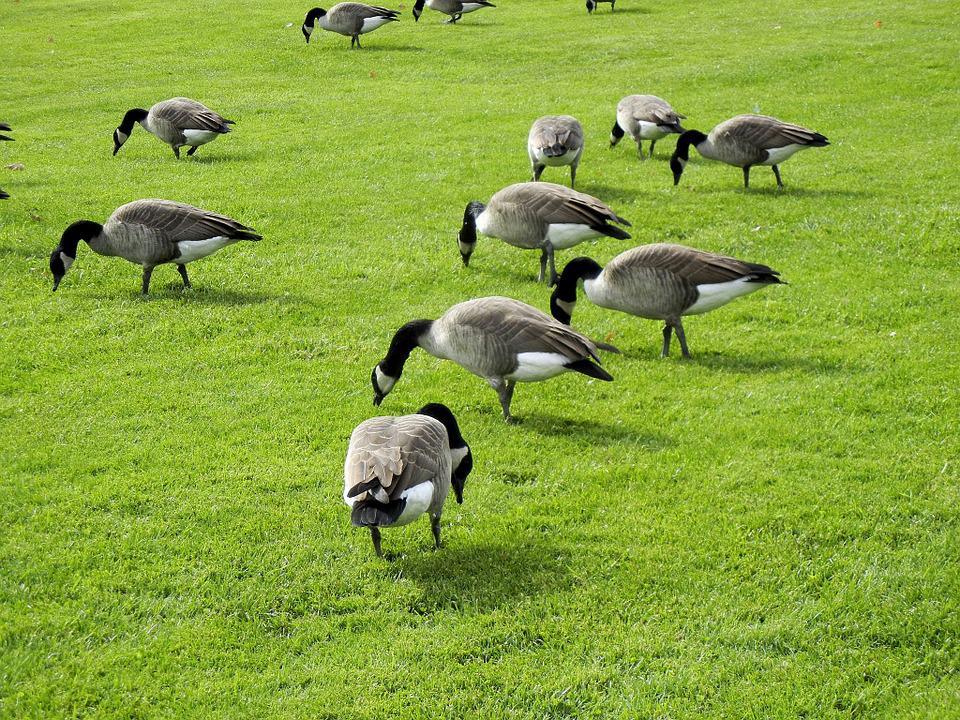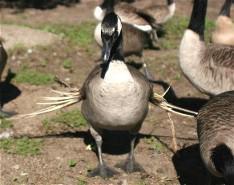The first image is the image on the left, the second image is the image on the right. Assess this claim about the two images: "in at least one image there are geese eating the grass". Correct or not? Answer yes or no. Yes. The first image is the image on the left, the second image is the image on the right. Considering the images on both sides, is "One image has water fowl in the water." valid? Answer yes or no. No. 